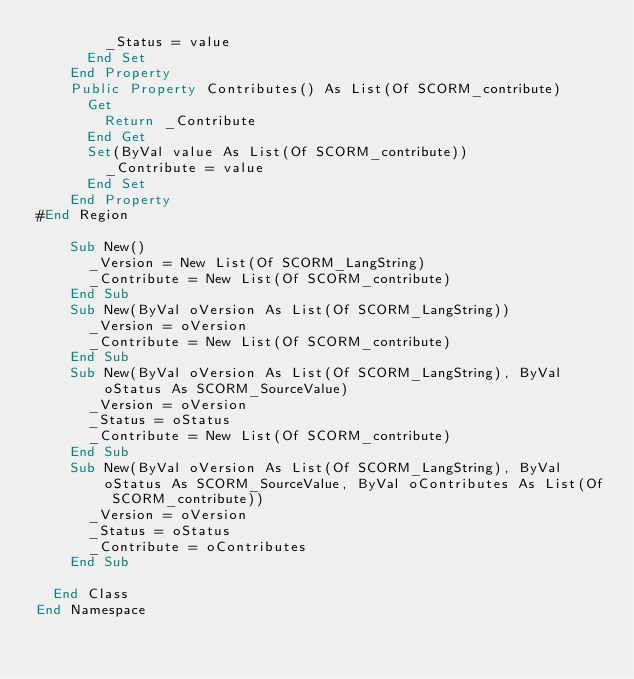Convert code to text. <code><loc_0><loc_0><loc_500><loc_500><_VisualBasic_>				_Status = value
			End Set
		End Property
		Public Property Contributes() As List(Of SCORM_contribute)
			Get
				Return _Contribute
			End Get
			Set(ByVal value As List(Of SCORM_contribute))
				_Contribute = value
			End Set
		End Property
#End Region

		Sub New()
			_Version = New List(Of SCORM_LangString)
			_Contribute = New List(Of SCORM_contribute)
		End Sub
		Sub New(ByVal oVersion As List(Of SCORM_LangString))
			_Version = oVersion
			_Contribute = New List(Of SCORM_contribute)
		End Sub
		Sub New(ByVal oVersion As List(Of SCORM_LangString), ByVal oStatus As SCORM_SourceValue)
			_Version = oVersion
			_Status = oStatus
			_Contribute = New List(Of SCORM_contribute)
		End Sub
		Sub New(ByVal oVersion As List(Of SCORM_LangString), ByVal oStatus As SCORM_SourceValue, ByVal oContributes As List(Of SCORM_contribute))
			_Version = oVersion
			_Status = oStatus
			_Contribute = oContributes
		End Sub

	End Class
End Namespace</code> 